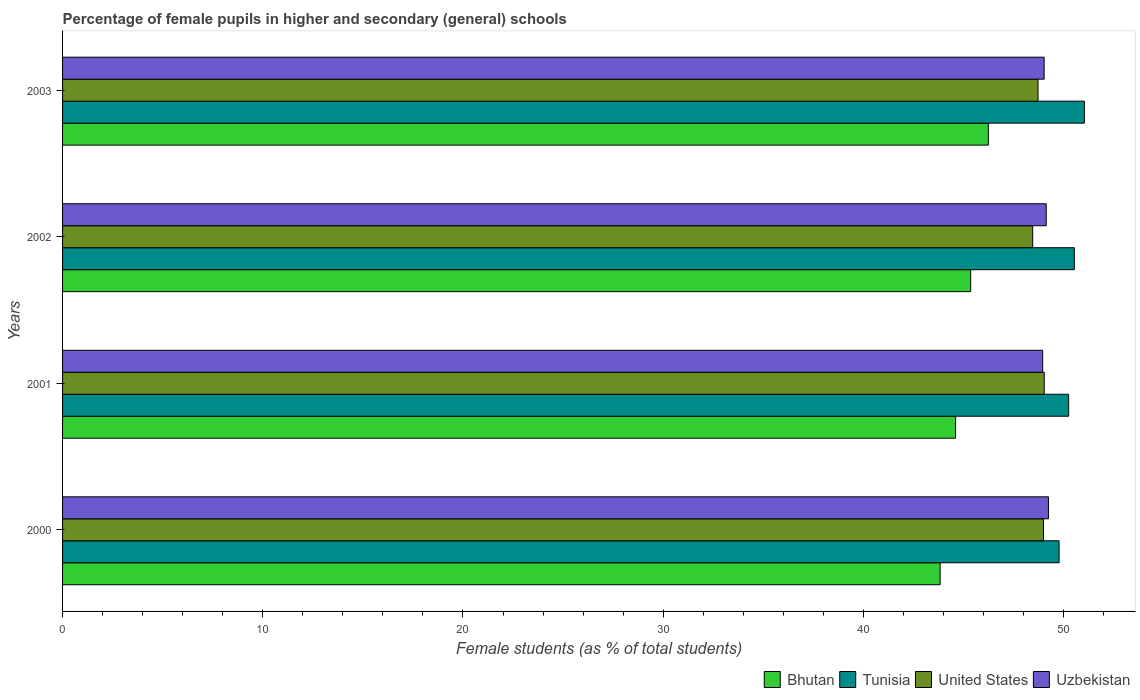How many different coloured bars are there?
Offer a terse response. 4. How many groups of bars are there?
Give a very brief answer. 4. Are the number of bars per tick equal to the number of legend labels?
Offer a terse response. Yes. How many bars are there on the 4th tick from the top?
Provide a succinct answer. 4. In how many cases, is the number of bars for a given year not equal to the number of legend labels?
Your answer should be very brief. 0. What is the percentage of female pupils in higher and secondary schools in United States in 2001?
Make the answer very short. 49.03. Across all years, what is the maximum percentage of female pupils in higher and secondary schools in United States?
Ensure brevity in your answer.  49.03. Across all years, what is the minimum percentage of female pupils in higher and secondary schools in Bhutan?
Your answer should be compact. 43.83. In which year was the percentage of female pupils in higher and secondary schools in Tunisia minimum?
Provide a short and direct response. 2000. What is the total percentage of female pupils in higher and secondary schools in United States in the graph?
Your answer should be very brief. 195.21. What is the difference between the percentage of female pupils in higher and secondary schools in Uzbekistan in 2000 and that in 2001?
Ensure brevity in your answer.  0.29. What is the difference between the percentage of female pupils in higher and secondary schools in Bhutan in 2003 and the percentage of female pupils in higher and secondary schools in United States in 2002?
Ensure brevity in your answer.  -2.21. What is the average percentage of female pupils in higher and secondary schools in Tunisia per year?
Your response must be concise. 50.4. In the year 2002, what is the difference between the percentage of female pupils in higher and secondary schools in Uzbekistan and percentage of female pupils in higher and secondary schools in United States?
Give a very brief answer. 0.68. In how many years, is the percentage of female pupils in higher and secondary schools in Bhutan greater than 42 %?
Make the answer very short. 4. What is the ratio of the percentage of female pupils in higher and secondary schools in United States in 2001 to that in 2002?
Make the answer very short. 1.01. Is the difference between the percentage of female pupils in higher and secondary schools in Uzbekistan in 2000 and 2003 greater than the difference between the percentage of female pupils in higher and secondary schools in United States in 2000 and 2003?
Provide a short and direct response. No. What is the difference between the highest and the second highest percentage of female pupils in higher and secondary schools in Bhutan?
Your answer should be very brief. 0.88. What is the difference between the highest and the lowest percentage of female pupils in higher and secondary schools in United States?
Your response must be concise. 0.58. In how many years, is the percentage of female pupils in higher and secondary schools in Bhutan greater than the average percentage of female pupils in higher and secondary schools in Bhutan taken over all years?
Provide a succinct answer. 2. Is the sum of the percentage of female pupils in higher and secondary schools in Bhutan in 2000 and 2003 greater than the maximum percentage of female pupils in higher and secondary schools in United States across all years?
Provide a short and direct response. Yes. Is it the case that in every year, the sum of the percentage of female pupils in higher and secondary schools in Tunisia and percentage of female pupils in higher and secondary schools in United States is greater than the sum of percentage of female pupils in higher and secondary schools in Bhutan and percentage of female pupils in higher and secondary schools in Uzbekistan?
Offer a terse response. Yes. What does the 3rd bar from the top in 2003 represents?
Give a very brief answer. Tunisia. What does the 4th bar from the bottom in 2002 represents?
Give a very brief answer. Uzbekistan. How many years are there in the graph?
Your answer should be very brief. 4. Does the graph contain any zero values?
Your answer should be compact. No. Where does the legend appear in the graph?
Your answer should be compact. Bottom right. How many legend labels are there?
Keep it short and to the point. 4. How are the legend labels stacked?
Your answer should be very brief. Horizontal. What is the title of the graph?
Your answer should be very brief. Percentage of female pupils in higher and secondary (general) schools. What is the label or title of the X-axis?
Make the answer very short. Female students (as % of total students). What is the Female students (as % of total students) in Bhutan in 2000?
Your answer should be very brief. 43.83. What is the Female students (as % of total students) of Tunisia in 2000?
Your response must be concise. 49.78. What is the Female students (as % of total students) in United States in 2000?
Your answer should be very brief. 49. What is the Female students (as % of total students) of Uzbekistan in 2000?
Provide a succinct answer. 49.24. What is the Female students (as % of total students) of Bhutan in 2001?
Offer a very short reply. 44.6. What is the Female students (as % of total students) of Tunisia in 2001?
Offer a very short reply. 50.25. What is the Female students (as % of total students) in United States in 2001?
Provide a succinct answer. 49.03. What is the Female students (as % of total students) in Uzbekistan in 2001?
Your answer should be compact. 48.96. What is the Female students (as % of total students) in Bhutan in 2002?
Provide a short and direct response. 45.36. What is the Female students (as % of total students) in Tunisia in 2002?
Keep it short and to the point. 50.54. What is the Female students (as % of total students) of United States in 2002?
Make the answer very short. 48.46. What is the Female students (as % of total students) in Uzbekistan in 2002?
Keep it short and to the point. 49.13. What is the Female students (as % of total students) of Bhutan in 2003?
Provide a short and direct response. 46.24. What is the Female students (as % of total students) of Tunisia in 2003?
Provide a short and direct response. 51.04. What is the Female students (as % of total students) in United States in 2003?
Ensure brevity in your answer.  48.72. What is the Female students (as % of total students) of Uzbekistan in 2003?
Make the answer very short. 49.03. Across all years, what is the maximum Female students (as % of total students) in Bhutan?
Provide a succinct answer. 46.24. Across all years, what is the maximum Female students (as % of total students) in Tunisia?
Provide a short and direct response. 51.04. Across all years, what is the maximum Female students (as % of total students) in United States?
Your answer should be very brief. 49.03. Across all years, what is the maximum Female students (as % of total students) in Uzbekistan?
Make the answer very short. 49.24. Across all years, what is the minimum Female students (as % of total students) in Bhutan?
Provide a succinct answer. 43.83. Across all years, what is the minimum Female students (as % of total students) in Tunisia?
Ensure brevity in your answer.  49.78. Across all years, what is the minimum Female students (as % of total students) in United States?
Give a very brief answer. 48.46. Across all years, what is the minimum Female students (as % of total students) in Uzbekistan?
Provide a short and direct response. 48.96. What is the total Female students (as % of total students) in Bhutan in the graph?
Your answer should be very brief. 180.04. What is the total Female students (as % of total students) in Tunisia in the graph?
Your answer should be compact. 201.61. What is the total Female students (as % of total students) in United States in the graph?
Your answer should be compact. 195.21. What is the total Female students (as % of total students) of Uzbekistan in the graph?
Ensure brevity in your answer.  196.36. What is the difference between the Female students (as % of total students) of Bhutan in 2000 and that in 2001?
Your response must be concise. -0.77. What is the difference between the Female students (as % of total students) of Tunisia in 2000 and that in 2001?
Provide a short and direct response. -0.48. What is the difference between the Female students (as % of total students) of United States in 2000 and that in 2001?
Provide a succinct answer. -0.04. What is the difference between the Female students (as % of total students) in Uzbekistan in 2000 and that in 2001?
Your response must be concise. 0.29. What is the difference between the Female students (as % of total students) in Bhutan in 2000 and that in 2002?
Give a very brief answer. -1.53. What is the difference between the Female students (as % of total students) in Tunisia in 2000 and that in 2002?
Give a very brief answer. -0.76. What is the difference between the Female students (as % of total students) in United States in 2000 and that in 2002?
Provide a short and direct response. 0.54. What is the difference between the Female students (as % of total students) in Uzbekistan in 2000 and that in 2002?
Make the answer very short. 0.11. What is the difference between the Female students (as % of total students) of Bhutan in 2000 and that in 2003?
Your response must be concise. -2.41. What is the difference between the Female students (as % of total students) in Tunisia in 2000 and that in 2003?
Offer a very short reply. -1.26. What is the difference between the Female students (as % of total students) in United States in 2000 and that in 2003?
Your answer should be compact. 0.27. What is the difference between the Female students (as % of total students) of Uzbekistan in 2000 and that in 2003?
Offer a terse response. 0.22. What is the difference between the Female students (as % of total students) of Bhutan in 2001 and that in 2002?
Ensure brevity in your answer.  -0.76. What is the difference between the Female students (as % of total students) in Tunisia in 2001 and that in 2002?
Make the answer very short. -0.28. What is the difference between the Female students (as % of total students) of United States in 2001 and that in 2002?
Give a very brief answer. 0.58. What is the difference between the Female students (as % of total students) in Uzbekistan in 2001 and that in 2002?
Ensure brevity in your answer.  -0.18. What is the difference between the Female students (as % of total students) of Bhutan in 2001 and that in 2003?
Your answer should be compact. -1.64. What is the difference between the Female students (as % of total students) in Tunisia in 2001 and that in 2003?
Make the answer very short. -0.79. What is the difference between the Female students (as % of total students) of United States in 2001 and that in 2003?
Provide a short and direct response. 0.31. What is the difference between the Female students (as % of total students) in Uzbekistan in 2001 and that in 2003?
Make the answer very short. -0.07. What is the difference between the Female students (as % of total students) of Bhutan in 2002 and that in 2003?
Give a very brief answer. -0.88. What is the difference between the Female students (as % of total students) of Tunisia in 2002 and that in 2003?
Your answer should be very brief. -0.5. What is the difference between the Female students (as % of total students) of United States in 2002 and that in 2003?
Offer a terse response. -0.27. What is the difference between the Female students (as % of total students) of Uzbekistan in 2002 and that in 2003?
Make the answer very short. 0.1. What is the difference between the Female students (as % of total students) of Bhutan in 2000 and the Female students (as % of total students) of Tunisia in 2001?
Make the answer very short. -6.42. What is the difference between the Female students (as % of total students) of Bhutan in 2000 and the Female students (as % of total students) of United States in 2001?
Provide a short and direct response. -5.2. What is the difference between the Female students (as % of total students) in Bhutan in 2000 and the Female students (as % of total students) in Uzbekistan in 2001?
Your response must be concise. -5.12. What is the difference between the Female students (as % of total students) in Tunisia in 2000 and the Female students (as % of total students) in United States in 2001?
Offer a terse response. 0.74. What is the difference between the Female students (as % of total students) in Tunisia in 2000 and the Female students (as % of total students) in Uzbekistan in 2001?
Provide a succinct answer. 0.82. What is the difference between the Female students (as % of total students) of United States in 2000 and the Female students (as % of total students) of Uzbekistan in 2001?
Give a very brief answer. 0.04. What is the difference between the Female students (as % of total students) in Bhutan in 2000 and the Female students (as % of total students) in Tunisia in 2002?
Your answer should be compact. -6.7. What is the difference between the Female students (as % of total students) in Bhutan in 2000 and the Female students (as % of total students) in United States in 2002?
Provide a succinct answer. -4.62. What is the difference between the Female students (as % of total students) of Bhutan in 2000 and the Female students (as % of total students) of Uzbekistan in 2002?
Offer a very short reply. -5.3. What is the difference between the Female students (as % of total students) of Tunisia in 2000 and the Female students (as % of total students) of United States in 2002?
Ensure brevity in your answer.  1.32. What is the difference between the Female students (as % of total students) of Tunisia in 2000 and the Female students (as % of total students) of Uzbekistan in 2002?
Your answer should be very brief. 0.64. What is the difference between the Female students (as % of total students) of United States in 2000 and the Female students (as % of total students) of Uzbekistan in 2002?
Offer a very short reply. -0.14. What is the difference between the Female students (as % of total students) in Bhutan in 2000 and the Female students (as % of total students) in Tunisia in 2003?
Provide a succinct answer. -7.21. What is the difference between the Female students (as % of total students) of Bhutan in 2000 and the Female students (as % of total students) of United States in 2003?
Your response must be concise. -4.89. What is the difference between the Female students (as % of total students) of Bhutan in 2000 and the Female students (as % of total students) of Uzbekistan in 2003?
Your answer should be compact. -5.2. What is the difference between the Female students (as % of total students) in Tunisia in 2000 and the Female students (as % of total students) in United States in 2003?
Offer a very short reply. 1.05. What is the difference between the Female students (as % of total students) of Tunisia in 2000 and the Female students (as % of total students) of Uzbekistan in 2003?
Give a very brief answer. 0.75. What is the difference between the Female students (as % of total students) in United States in 2000 and the Female students (as % of total students) in Uzbekistan in 2003?
Make the answer very short. -0.03. What is the difference between the Female students (as % of total students) in Bhutan in 2001 and the Female students (as % of total students) in Tunisia in 2002?
Give a very brief answer. -5.93. What is the difference between the Female students (as % of total students) of Bhutan in 2001 and the Female students (as % of total students) of United States in 2002?
Make the answer very short. -3.85. What is the difference between the Female students (as % of total students) of Bhutan in 2001 and the Female students (as % of total students) of Uzbekistan in 2002?
Ensure brevity in your answer.  -4.53. What is the difference between the Female students (as % of total students) in Tunisia in 2001 and the Female students (as % of total students) in United States in 2002?
Offer a very short reply. 1.8. What is the difference between the Female students (as % of total students) of Tunisia in 2001 and the Female students (as % of total students) of Uzbekistan in 2002?
Offer a very short reply. 1.12. What is the difference between the Female students (as % of total students) of United States in 2001 and the Female students (as % of total students) of Uzbekistan in 2002?
Your answer should be compact. -0.1. What is the difference between the Female students (as % of total students) of Bhutan in 2001 and the Female students (as % of total students) of Tunisia in 2003?
Your response must be concise. -6.44. What is the difference between the Female students (as % of total students) in Bhutan in 2001 and the Female students (as % of total students) in United States in 2003?
Offer a very short reply. -4.12. What is the difference between the Female students (as % of total students) of Bhutan in 2001 and the Female students (as % of total students) of Uzbekistan in 2003?
Give a very brief answer. -4.43. What is the difference between the Female students (as % of total students) of Tunisia in 2001 and the Female students (as % of total students) of United States in 2003?
Provide a short and direct response. 1.53. What is the difference between the Female students (as % of total students) in Tunisia in 2001 and the Female students (as % of total students) in Uzbekistan in 2003?
Make the answer very short. 1.23. What is the difference between the Female students (as % of total students) of United States in 2001 and the Female students (as % of total students) of Uzbekistan in 2003?
Ensure brevity in your answer.  0.01. What is the difference between the Female students (as % of total students) in Bhutan in 2002 and the Female students (as % of total students) in Tunisia in 2003?
Offer a terse response. -5.68. What is the difference between the Female students (as % of total students) of Bhutan in 2002 and the Female students (as % of total students) of United States in 2003?
Offer a terse response. -3.36. What is the difference between the Female students (as % of total students) of Bhutan in 2002 and the Female students (as % of total students) of Uzbekistan in 2003?
Provide a succinct answer. -3.67. What is the difference between the Female students (as % of total students) of Tunisia in 2002 and the Female students (as % of total students) of United States in 2003?
Your response must be concise. 1.81. What is the difference between the Female students (as % of total students) of Tunisia in 2002 and the Female students (as % of total students) of Uzbekistan in 2003?
Your answer should be compact. 1.51. What is the difference between the Female students (as % of total students) of United States in 2002 and the Female students (as % of total students) of Uzbekistan in 2003?
Your response must be concise. -0.57. What is the average Female students (as % of total students) of Bhutan per year?
Provide a short and direct response. 45.01. What is the average Female students (as % of total students) in Tunisia per year?
Provide a short and direct response. 50.4. What is the average Female students (as % of total students) of United States per year?
Your answer should be compact. 48.8. What is the average Female students (as % of total students) of Uzbekistan per year?
Keep it short and to the point. 49.09. In the year 2000, what is the difference between the Female students (as % of total students) of Bhutan and Female students (as % of total students) of Tunisia?
Your answer should be very brief. -5.94. In the year 2000, what is the difference between the Female students (as % of total students) of Bhutan and Female students (as % of total students) of United States?
Offer a terse response. -5.16. In the year 2000, what is the difference between the Female students (as % of total students) in Bhutan and Female students (as % of total students) in Uzbekistan?
Your answer should be compact. -5.41. In the year 2000, what is the difference between the Female students (as % of total students) of Tunisia and Female students (as % of total students) of United States?
Ensure brevity in your answer.  0.78. In the year 2000, what is the difference between the Female students (as % of total students) of Tunisia and Female students (as % of total students) of Uzbekistan?
Provide a short and direct response. 0.53. In the year 2000, what is the difference between the Female students (as % of total students) of United States and Female students (as % of total students) of Uzbekistan?
Make the answer very short. -0.25. In the year 2001, what is the difference between the Female students (as % of total students) of Bhutan and Female students (as % of total students) of Tunisia?
Your response must be concise. -5.65. In the year 2001, what is the difference between the Female students (as % of total students) in Bhutan and Female students (as % of total students) in United States?
Your answer should be very brief. -4.43. In the year 2001, what is the difference between the Female students (as % of total students) of Bhutan and Female students (as % of total students) of Uzbekistan?
Give a very brief answer. -4.35. In the year 2001, what is the difference between the Female students (as % of total students) in Tunisia and Female students (as % of total students) in United States?
Offer a very short reply. 1.22. In the year 2001, what is the difference between the Female students (as % of total students) of Tunisia and Female students (as % of total students) of Uzbekistan?
Provide a short and direct response. 1.3. In the year 2001, what is the difference between the Female students (as % of total students) in United States and Female students (as % of total students) in Uzbekistan?
Ensure brevity in your answer.  0.08. In the year 2002, what is the difference between the Female students (as % of total students) of Bhutan and Female students (as % of total students) of Tunisia?
Offer a very short reply. -5.18. In the year 2002, what is the difference between the Female students (as % of total students) of Bhutan and Female students (as % of total students) of United States?
Keep it short and to the point. -3.1. In the year 2002, what is the difference between the Female students (as % of total students) of Bhutan and Female students (as % of total students) of Uzbekistan?
Keep it short and to the point. -3.77. In the year 2002, what is the difference between the Female students (as % of total students) of Tunisia and Female students (as % of total students) of United States?
Your response must be concise. 2.08. In the year 2002, what is the difference between the Female students (as % of total students) of Tunisia and Female students (as % of total students) of Uzbekistan?
Ensure brevity in your answer.  1.4. In the year 2002, what is the difference between the Female students (as % of total students) of United States and Female students (as % of total students) of Uzbekistan?
Your answer should be very brief. -0.68. In the year 2003, what is the difference between the Female students (as % of total students) of Bhutan and Female students (as % of total students) of Tunisia?
Provide a succinct answer. -4.8. In the year 2003, what is the difference between the Female students (as % of total students) in Bhutan and Female students (as % of total students) in United States?
Your answer should be compact. -2.48. In the year 2003, what is the difference between the Female students (as % of total students) in Bhutan and Female students (as % of total students) in Uzbekistan?
Provide a short and direct response. -2.79. In the year 2003, what is the difference between the Female students (as % of total students) in Tunisia and Female students (as % of total students) in United States?
Give a very brief answer. 2.32. In the year 2003, what is the difference between the Female students (as % of total students) in Tunisia and Female students (as % of total students) in Uzbekistan?
Provide a succinct answer. 2.01. In the year 2003, what is the difference between the Female students (as % of total students) of United States and Female students (as % of total students) of Uzbekistan?
Keep it short and to the point. -0.31. What is the ratio of the Female students (as % of total students) in Bhutan in 2000 to that in 2001?
Provide a succinct answer. 0.98. What is the ratio of the Female students (as % of total students) in United States in 2000 to that in 2001?
Make the answer very short. 1. What is the ratio of the Female students (as % of total students) of Uzbekistan in 2000 to that in 2001?
Keep it short and to the point. 1.01. What is the ratio of the Female students (as % of total students) in Bhutan in 2000 to that in 2002?
Offer a terse response. 0.97. What is the ratio of the Female students (as % of total students) of Tunisia in 2000 to that in 2002?
Your answer should be very brief. 0.98. What is the ratio of the Female students (as % of total students) of United States in 2000 to that in 2002?
Provide a succinct answer. 1.01. What is the ratio of the Female students (as % of total students) of Uzbekistan in 2000 to that in 2002?
Make the answer very short. 1. What is the ratio of the Female students (as % of total students) in Bhutan in 2000 to that in 2003?
Make the answer very short. 0.95. What is the ratio of the Female students (as % of total students) of Tunisia in 2000 to that in 2003?
Offer a terse response. 0.98. What is the ratio of the Female students (as % of total students) of United States in 2000 to that in 2003?
Make the answer very short. 1.01. What is the ratio of the Female students (as % of total students) in Bhutan in 2001 to that in 2002?
Provide a succinct answer. 0.98. What is the ratio of the Female students (as % of total students) in Tunisia in 2001 to that in 2002?
Offer a terse response. 0.99. What is the ratio of the Female students (as % of total students) in United States in 2001 to that in 2002?
Your response must be concise. 1.01. What is the ratio of the Female students (as % of total students) in Bhutan in 2001 to that in 2003?
Provide a short and direct response. 0.96. What is the ratio of the Female students (as % of total students) of Tunisia in 2001 to that in 2003?
Your response must be concise. 0.98. What is the ratio of the Female students (as % of total students) in United States in 2001 to that in 2003?
Keep it short and to the point. 1.01. What is the ratio of the Female students (as % of total students) in Bhutan in 2002 to that in 2003?
Ensure brevity in your answer.  0.98. What is the ratio of the Female students (as % of total students) in Tunisia in 2002 to that in 2003?
Your answer should be very brief. 0.99. What is the ratio of the Female students (as % of total students) in United States in 2002 to that in 2003?
Ensure brevity in your answer.  0.99. What is the difference between the highest and the second highest Female students (as % of total students) of Bhutan?
Give a very brief answer. 0.88. What is the difference between the highest and the second highest Female students (as % of total students) in Tunisia?
Your answer should be compact. 0.5. What is the difference between the highest and the second highest Female students (as % of total students) in United States?
Ensure brevity in your answer.  0.04. What is the difference between the highest and the second highest Female students (as % of total students) of Uzbekistan?
Give a very brief answer. 0.11. What is the difference between the highest and the lowest Female students (as % of total students) of Bhutan?
Provide a succinct answer. 2.41. What is the difference between the highest and the lowest Female students (as % of total students) of Tunisia?
Make the answer very short. 1.26. What is the difference between the highest and the lowest Female students (as % of total students) of United States?
Provide a short and direct response. 0.58. What is the difference between the highest and the lowest Female students (as % of total students) in Uzbekistan?
Offer a terse response. 0.29. 